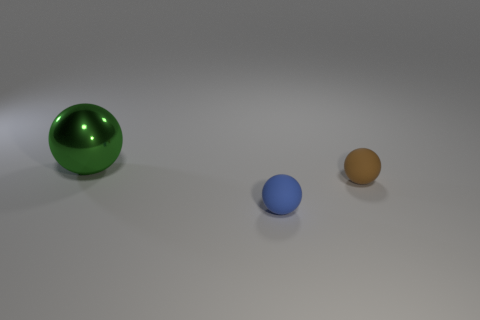There is a small thing behind the blue rubber sphere; what is it made of?
Ensure brevity in your answer.  Rubber. Is there a blue thing of the same size as the blue rubber ball?
Offer a very short reply. No. There is a small rubber ball right of the small blue sphere; does it have the same color as the metal sphere?
Offer a terse response. No. How many green things are tiny balls or large spheres?
Give a very brief answer. 1. What number of tiny spheres are the same color as the shiny object?
Give a very brief answer. 0. Does the large green ball have the same material as the tiny blue ball?
Provide a short and direct response. No. How many things are in front of the ball that is behind the tiny brown ball?
Your response must be concise. 2. Do the brown matte thing and the blue matte ball have the same size?
Your answer should be compact. Yes. How many tiny balls have the same material as the large thing?
Provide a short and direct response. 0. What is the size of the blue thing that is the same shape as the green shiny thing?
Your response must be concise. Small. 